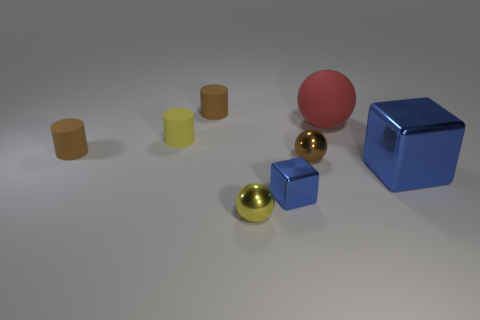What is the size of the red thing?
Your answer should be compact. Large. There is another block that is the same color as the large block; what is it made of?
Give a very brief answer. Metal. How many objects are tiny shiny things right of the tiny yellow metallic object or green shiny cylinders?
Offer a terse response. 2. The block that is made of the same material as the small blue object is what color?
Offer a very short reply. Blue. Is there a brown ball that has the same size as the yellow cylinder?
Offer a very short reply. Yes. Is the color of the tiny shiny cube behind the yellow metal object the same as the big shiny block?
Your answer should be very brief. Yes. There is a tiny thing that is both in front of the brown metal thing and to the left of the small blue object; what is its color?
Your answer should be very brief. Yellow. What shape is the yellow rubber thing that is the same size as the yellow ball?
Keep it short and to the point. Cylinder. Is there a tiny brown matte thing that has the same shape as the large red thing?
Offer a very short reply. No. There is a metal block that is to the left of the brown metal ball; does it have the same size as the large matte ball?
Your response must be concise. No. 